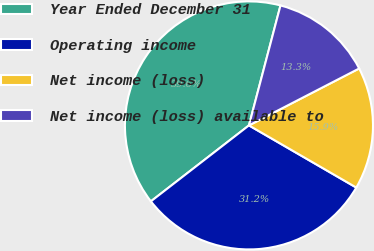Convert chart to OTSL. <chart><loc_0><loc_0><loc_500><loc_500><pie_chart><fcel>Year Ended December 31<fcel>Operating income<fcel>Net income (loss)<fcel>Net income (loss) available to<nl><fcel>39.58%<fcel>31.16%<fcel>15.94%<fcel>13.32%<nl></chart> 